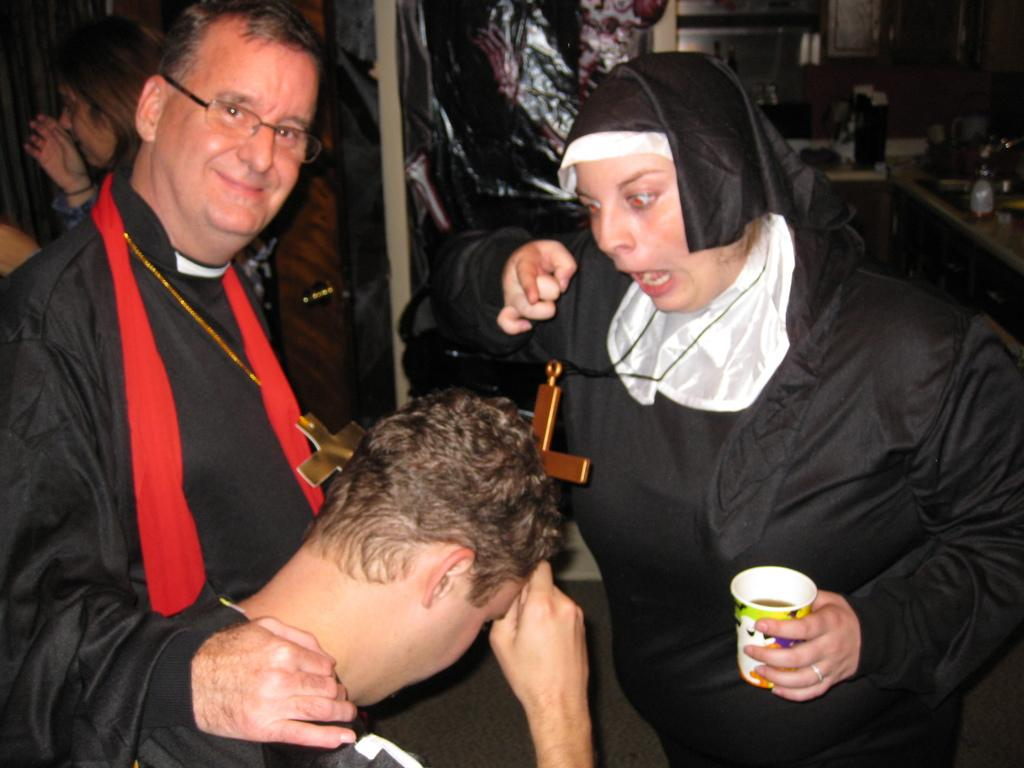What is the main subject of the image? The main subject of the image is a group of people. Can you describe the lady in the image? The lady is holding a glass in her hand. Where is the lady located in the image? The lady is at the rightmost part of the image. What type of toothbrush is the lady using in the image? There is no toothbrush present in the image. How much wealth is visible in the image? The concept of wealth is not mentioned or depicted in the image. 